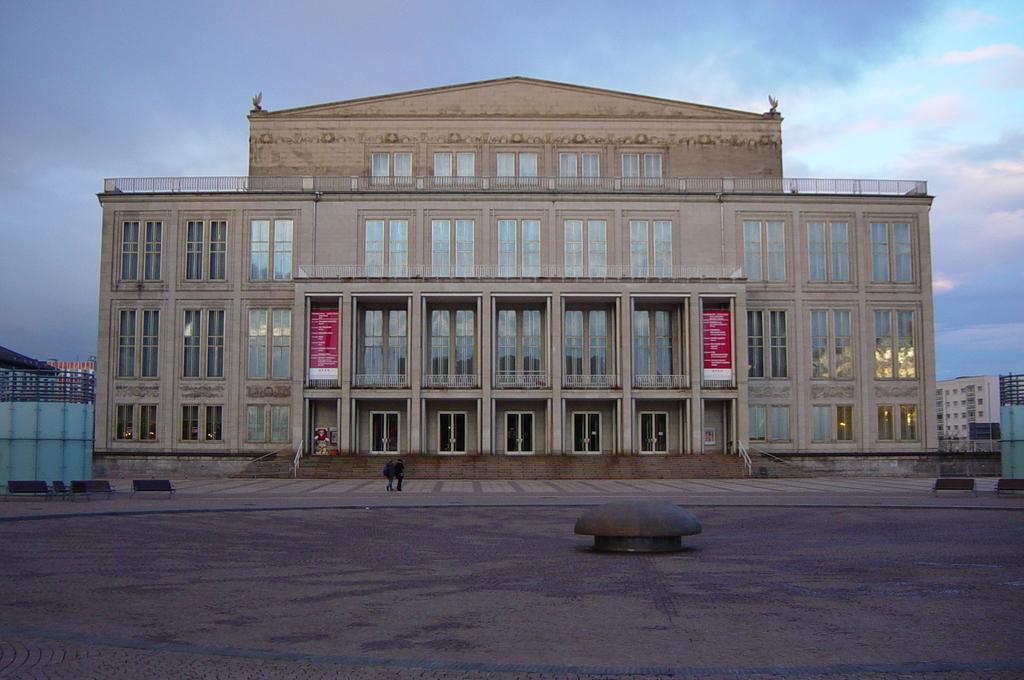Describe this image in one or two sentences. In this image there are two persons standing in middle of this image and there is a building in the background. There is a sky at top of this image and there is a ground at bottom of this image. 